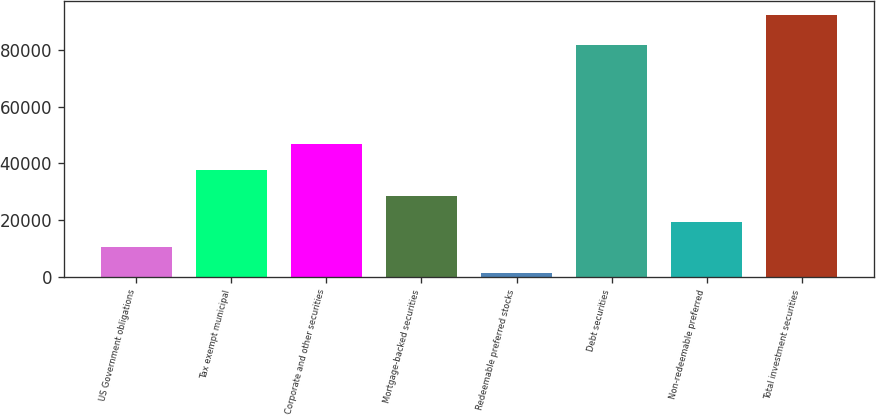<chart> <loc_0><loc_0><loc_500><loc_500><bar_chart><fcel>US Government obligations<fcel>Tax exempt municipal<fcel>Corporate and other securities<fcel>Mortgage-backed securities<fcel>Redeemable preferred stocks<fcel>Debt securities<fcel>Non-redeemable preferred<fcel>Total investment securities<nl><fcel>10368.9<fcel>37761.6<fcel>46892.5<fcel>28630.7<fcel>1238<fcel>81758<fcel>19499.8<fcel>92547<nl></chart> 